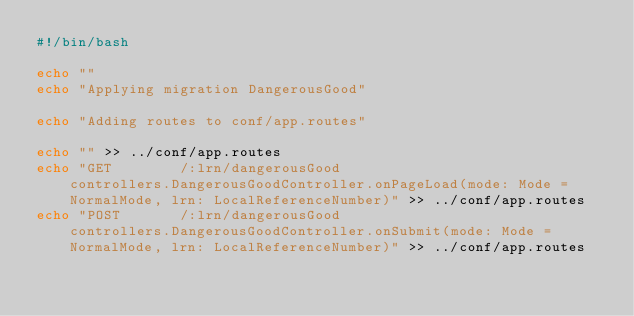<code> <loc_0><loc_0><loc_500><loc_500><_Bash_>#!/bin/bash

echo ""
echo "Applying migration DangerousGood"

echo "Adding routes to conf/app.routes"

echo "" >> ../conf/app.routes
echo "GET        /:lrn/dangerousGood                        controllers.DangerousGoodController.onPageLoad(mode: Mode = NormalMode, lrn: LocalReferenceNumber)" >> ../conf/app.routes
echo "POST       /:lrn/dangerousGood                        controllers.DangerousGoodController.onSubmit(mode: Mode = NormalMode, lrn: LocalReferenceNumber)" >> ../conf/app.routes
</code> 